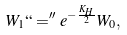Convert formula to latex. <formula><loc_0><loc_0><loc_500><loc_500>W _ { 1 } ` ` = ^ { \prime \prime } e ^ { - \frac { K _ { H } } { 2 } } W _ { 0 } ,</formula> 